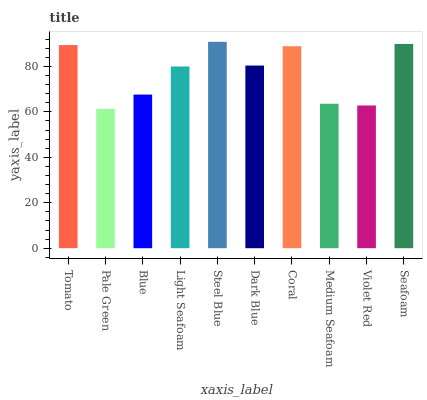Is Pale Green the minimum?
Answer yes or no. Yes. Is Steel Blue the maximum?
Answer yes or no. Yes. Is Blue the minimum?
Answer yes or no. No. Is Blue the maximum?
Answer yes or no. No. Is Blue greater than Pale Green?
Answer yes or no. Yes. Is Pale Green less than Blue?
Answer yes or no. Yes. Is Pale Green greater than Blue?
Answer yes or no. No. Is Blue less than Pale Green?
Answer yes or no. No. Is Dark Blue the high median?
Answer yes or no. Yes. Is Light Seafoam the low median?
Answer yes or no. Yes. Is Light Seafoam the high median?
Answer yes or no. No. Is Medium Seafoam the low median?
Answer yes or no. No. 